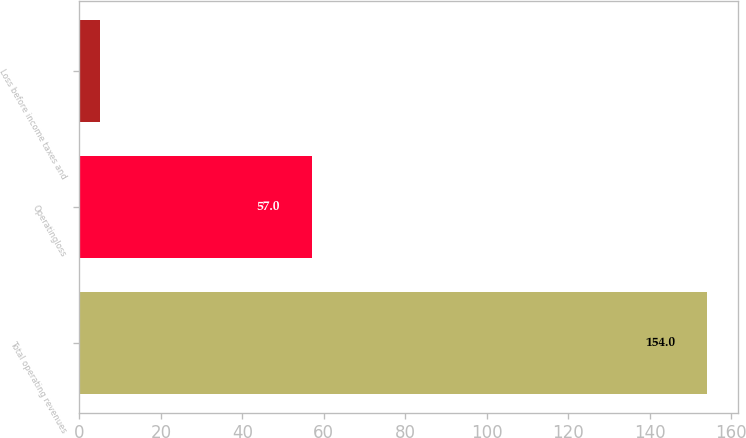<chart> <loc_0><loc_0><loc_500><loc_500><bar_chart><fcel>Total operating revenues<fcel>Operatingloss<fcel>Loss before income taxes and<nl><fcel>154<fcel>57<fcel>5<nl></chart> 